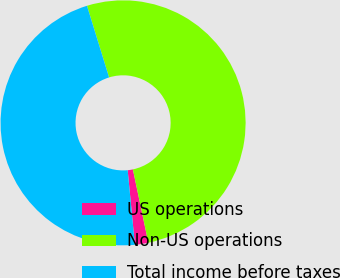<chart> <loc_0><loc_0><loc_500><loc_500><pie_chart><fcel>US operations<fcel>Non-US operations<fcel>Total income before taxes<nl><fcel>1.77%<fcel>51.45%<fcel>46.77%<nl></chart> 